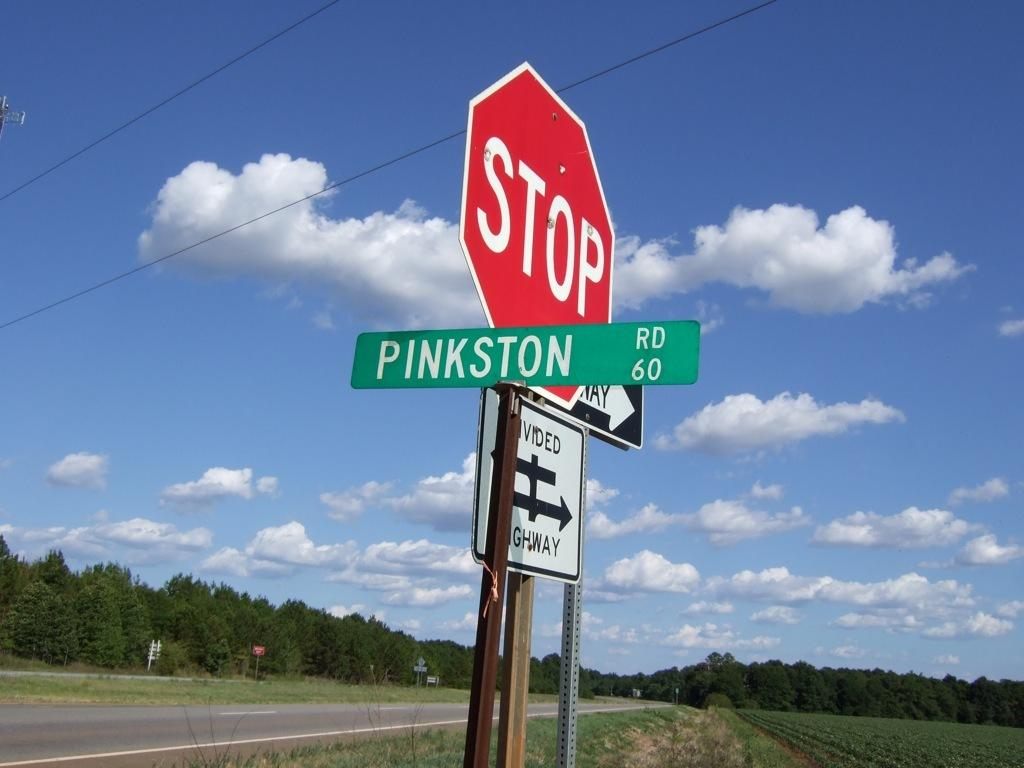<image>
Share a concise interpretation of the image provided. A sign for Pinkston Road is posted next to a stop sign. 